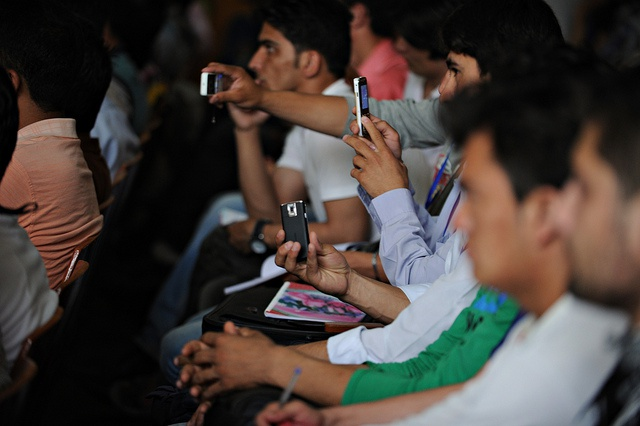Describe the objects in this image and their specific colors. I can see people in black, gray, darkgray, and lightgray tones, people in black, brown, and maroon tones, people in black, darkgray, brown, and maroon tones, people in black, gray, and brown tones, and people in black, darkgray, and gray tones in this image. 